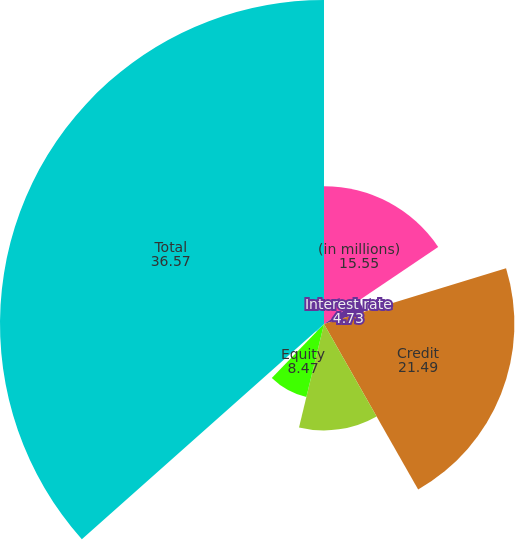Convert chart to OTSL. <chart><loc_0><loc_0><loc_500><loc_500><pie_chart><fcel>(in millions)<fcel>Interest rate<fcel>Credit<fcel>Foreign exchange (a)<fcel>Equity<fcel>Commodity<fcel>Total<nl><fcel>15.55%<fcel>4.73%<fcel>21.49%<fcel>12.01%<fcel>8.47%<fcel>1.19%<fcel>36.57%<nl></chart> 